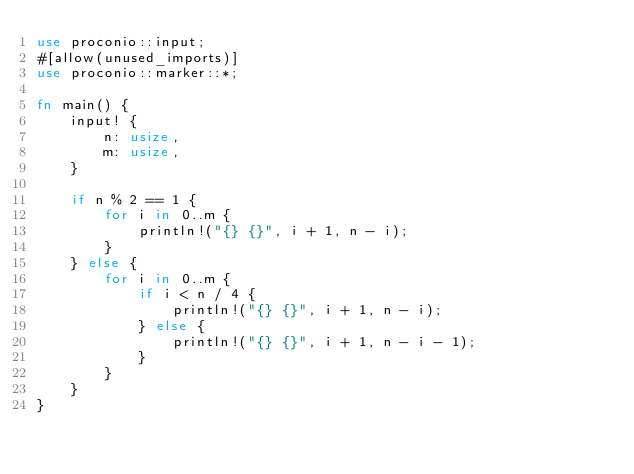Convert code to text. <code><loc_0><loc_0><loc_500><loc_500><_Rust_>use proconio::input;
#[allow(unused_imports)]
use proconio::marker::*;

fn main() {
    input! {
        n: usize,
        m: usize,
    }

    if n % 2 == 1 {
        for i in 0..m {
            println!("{} {}", i + 1, n - i);
        }
    } else {
        for i in 0..m {
            if i < n / 4 {
                println!("{} {}", i + 1, n - i);
            } else {
                println!("{} {}", i + 1, n - i - 1);
            }
        }
    }
}
</code> 